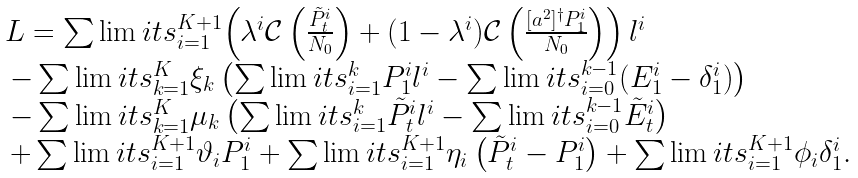Convert formula to latex. <formula><loc_0><loc_0><loc_500><loc_500>\begin{array} { l } L = \sum \lim i t s _ { i = 1 } ^ { K + 1 } { \left ( { { \lambda ^ { i } } \mathcal { C } \left ( \frac { \tilde { P } _ { t } ^ { i } } { N _ { 0 } } \right ) + ( 1 - { \lambda ^ { i } } ) \mathcal { C } \left ( \frac { { [ a ^ { 2 } ] ^ { \dag } } P _ { 1 } ^ { i } } { N _ { 0 } } \right ) } \right ) { l ^ { i } } } \\ \, - \sum \lim i t s _ { k = 1 } ^ { K } { { \xi _ { k } } \left ( { \sum \lim i t s _ { i = 1 } ^ { k } { P _ { 1 } ^ { i } { l ^ { i } } } - \sum \lim i t s _ { i = 0 } ^ { k - 1 } ( { E _ { 1 } ^ { i } } - { \delta _ { 1 } ^ { i } } ) } \right ) } \\ \, - \sum \lim i t s _ { k = 1 } ^ { K } { { \mu _ { k } } \left ( { \sum \lim i t s _ { i = 1 } ^ { k } { \tilde { P } _ { t } ^ { i } { l ^ { i } } } - \sum \lim i t s _ { i = 0 } ^ { k - 1 } { \tilde { E } _ { t } ^ { i } } } \right ) } \\ \, + \sum \lim i t s _ { i = 1 } ^ { K + 1 } { { \vartheta _ { i } } P _ { 1 } ^ { i } } + \sum \lim i t s _ { i = 1 } ^ { K + 1 } { { \eta _ { i } } \left ( \tilde { P } _ { t } ^ { i } - P _ { 1 } ^ { i } \right ) } + \sum \lim i t s _ { i = 1 } ^ { K + 1 } { { \phi _ { i } } \delta _ { 1 } ^ { i } } . \end{array}</formula> 